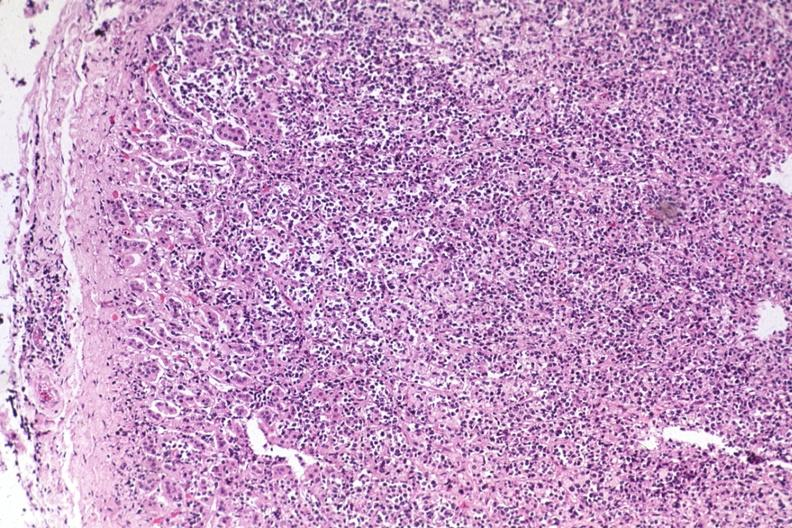s endocrine present?
Answer the question using a single word or phrase. Yes 